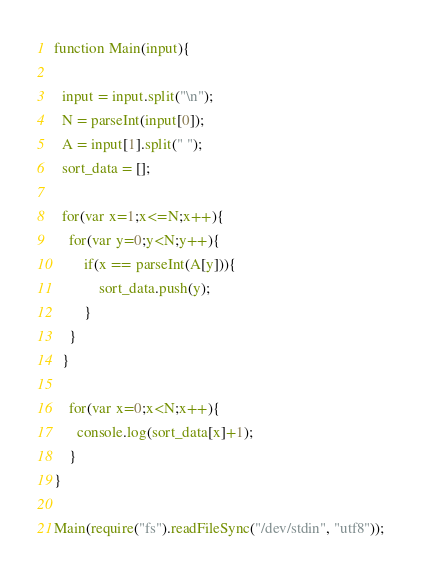<code> <loc_0><loc_0><loc_500><loc_500><_JavaScript_>function Main(input){
  
  input = input.split("\n");
  N = parseInt(input[0]);
  A = input[1].split(" ");
  sort_data = [];
  
  for(var x=1;x<=N;x++){
    for(var y=0;y<N;y++){
    	if(x == parseInt(A[y])){
      		sort_data.push(y);
        }
    }
  }
    
    for(var x=0;x<N;x++){
      console.log(sort_data[x]+1);
    }
}

Main(require("fs").readFileSync("/dev/stdin", "utf8"));</code> 